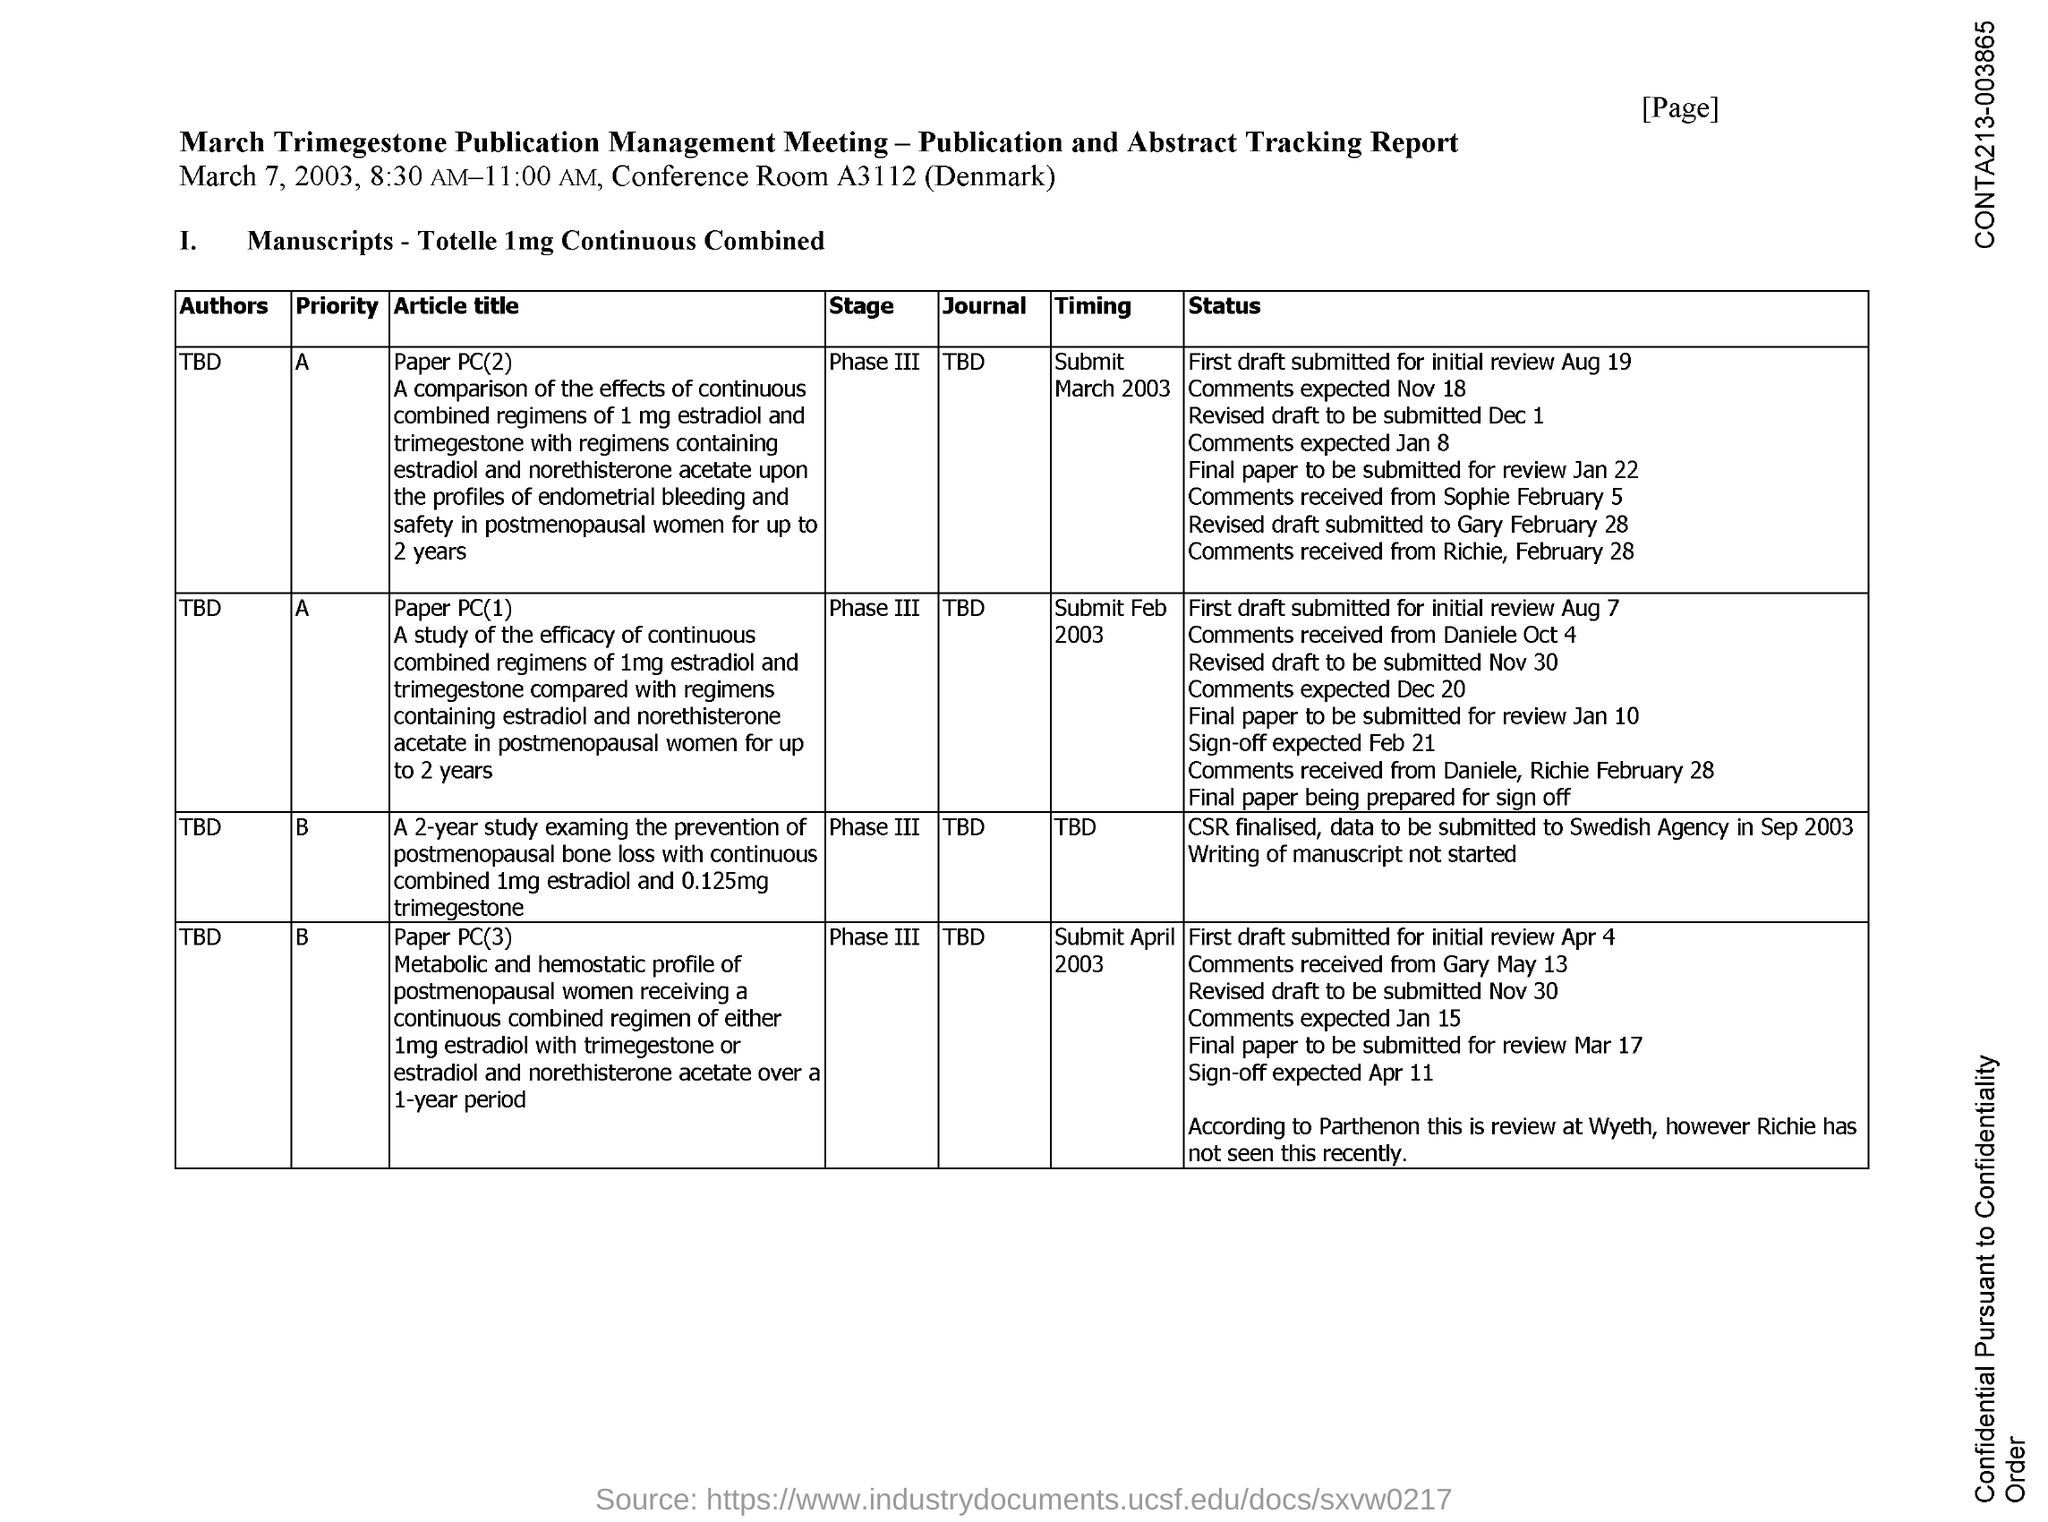What is the conference room number?
Your answer should be very brief. A3112 (Denmark). 